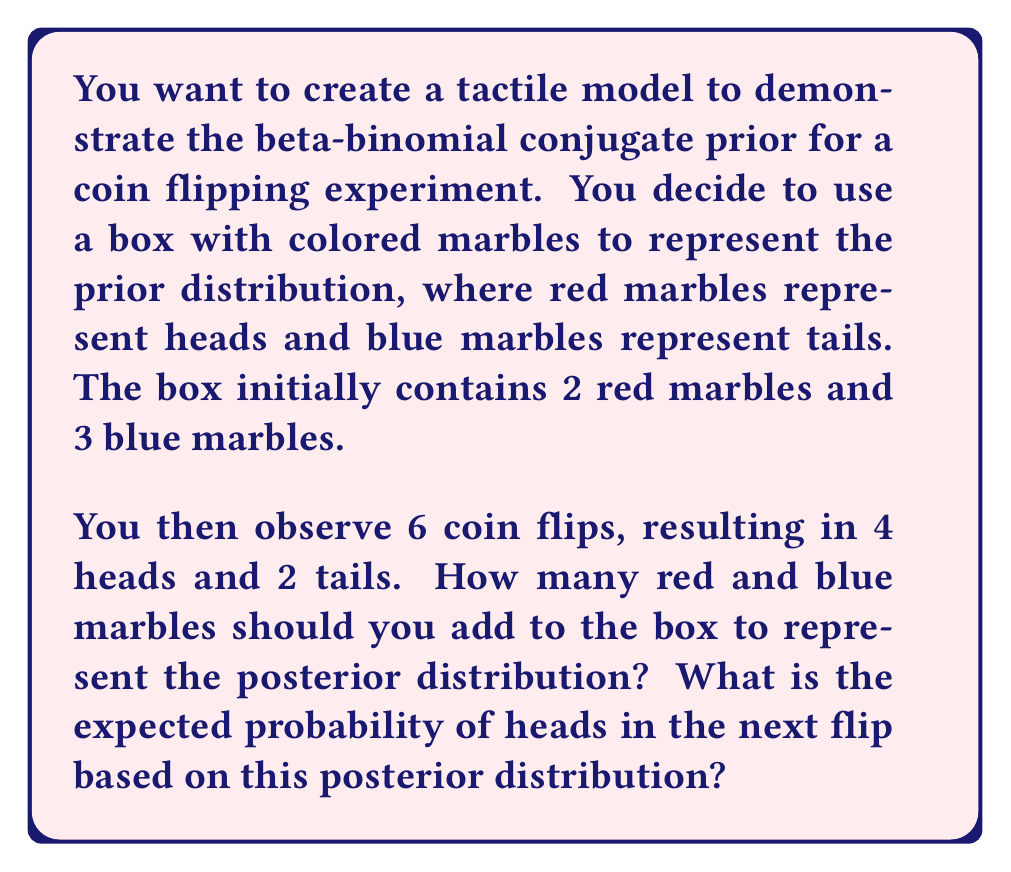Give your solution to this math problem. To create a tactile model for the beta-binomial conjugate prior, we can use the following approach:

1. Prior distribution:
   The initial box represents the prior Beta(α, β) distribution, where:
   α = number of red marbles = 2
   β = number of blue marbles = 3

2. Observed data:
   We observe 6 coin flips with 4 heads and 2 tails.

3. Posterior distribution:
   The posterior distribution is also a Beta distribution with updated parameters:
   α_posterior = α + number of heads = 2 + 4 = 6
   β_posterior = β + number of tails = 3 + 2 = 5

   To represent this in our tactile model, we need to add:
   - 4 red marbles (for the observed heads)
   - 2 blue marbles (for the observed tails)

4. Expected probability of heads:
   The expected probability of heads in the next flip is given by the mean of the Beta distribution:

   $$E[p] = \frac{\alpha_{\text{posterior}}}{\alpha_{\text{posterior}} + \beta_{\text{posterior}}} = \frac{6}{6 + 5} = \frac{6}{11} \approx 0.5455$$

This tactile model allows students to physically manipulate the marbles, adding them to the box as they observe data, and visually see how the proportion of red to blue marbles changes, representing the updating of probabilities in Bayesian inference.
Answer: Add 4 red marbles and 2 blue marbles to the box. The expected probability of heads in the next flip is $\frac{6}{11} \approx 0.5455$. 